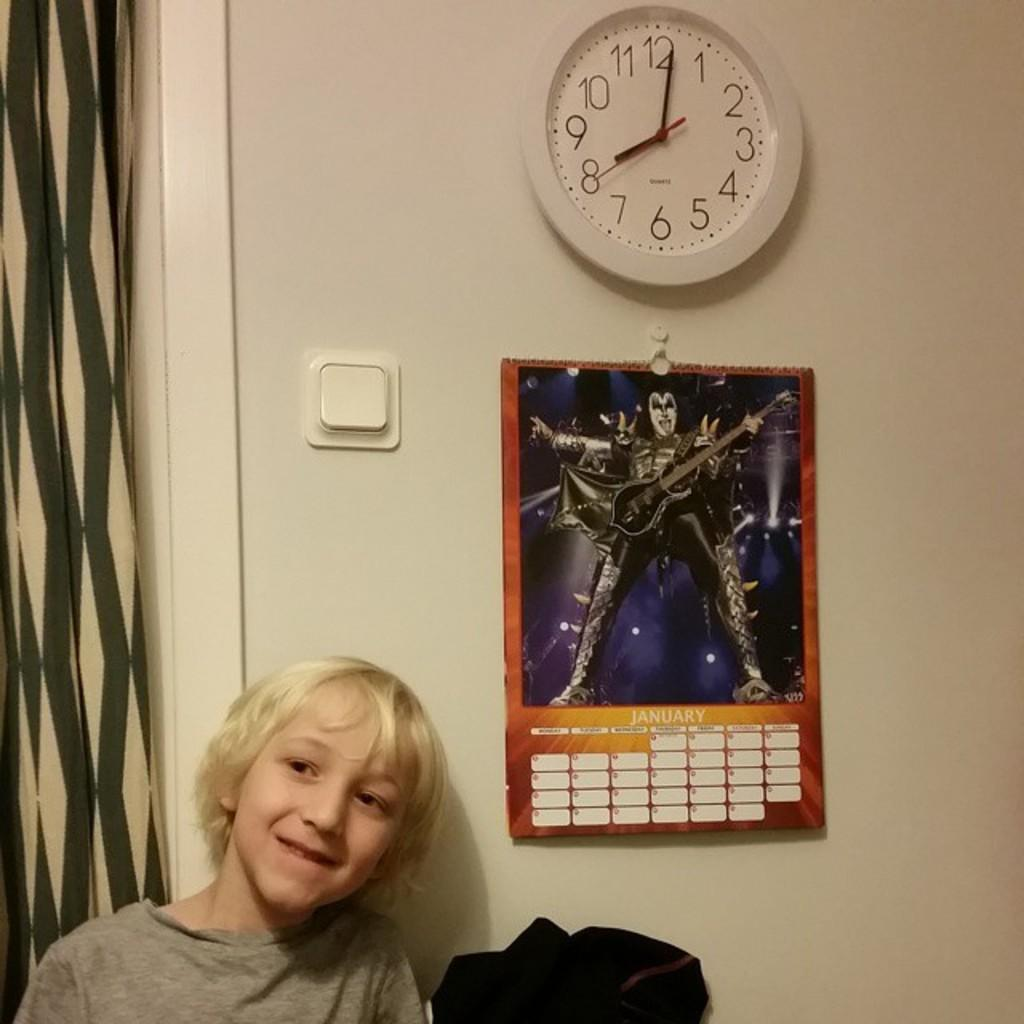<image>
Render a clear and concise summary of the photo. a kid near a wall that has a KISS calendar and clock at 8:00. 